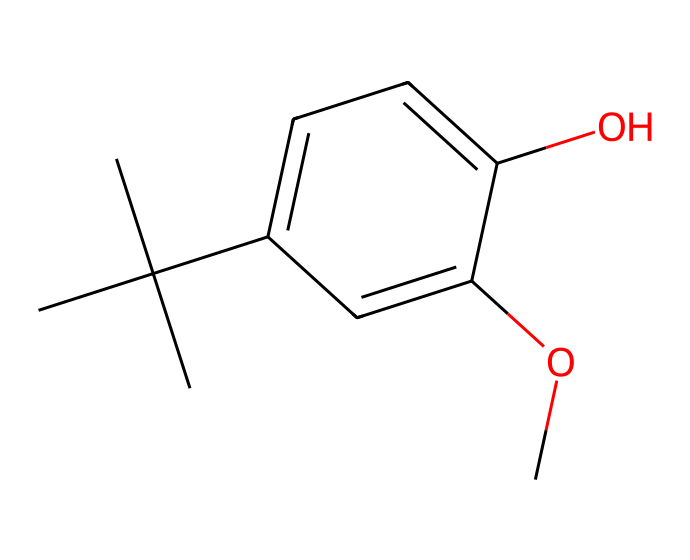What is the molecular formula of butylated hydroxyanisole (BHA)? To determine the molecular formula, count the number of each type of atom in the structure. The structure shows 11 carbon (C) atoms, 14 hydrogen (H) atoms, and 3 oxygen (O) atoms, leading to the formula C11H14O3.
Answer: C11H14O3 How many aromatic rings are present in the structure of BHA? The structure includes a single benzene ring, identified by the alternating double bonds and attached groups. Therefore, there is only one aromatic ring in BHA.
Answer: 1 What functional groups are found in butylated hydroxyanisole? The structure contains hydroxyl (-OH) and methoxy (-OCH3) groups, which are shown by the presence of the -OH attached to the benzene and the -OCH3 group attached to the same ring.
Answer: hydroxyl and methoxy What is the degree of saturation of BHA? The degree of saturation can be assessed by the presence of double bonds and rings. BHA has one benzene ring (contributing one degree of unsaturation) and no double bonds in the aliphatic carbon chain. Thus, it has a degree of saturation of 4.
Answer: 4 What type of chemical is butylated hydroxyanisole classified as? BHA is classified as an antioxidant preservative, which helps prevent oxidation in foods, as seen from its structural components that enable it to scavenge free radicals.
Answer: antioxidant preservative Why is butylated hydroxyanisole used as a preservative? BHA contains phenolic and methoxy groups that donate hydrogen atoms, allowing it to prevent oxidation by neutralizing free radicals that can spoil food. This function is crucial for its use as a preservative in packaged foods.
Answer: prevents oxidation 